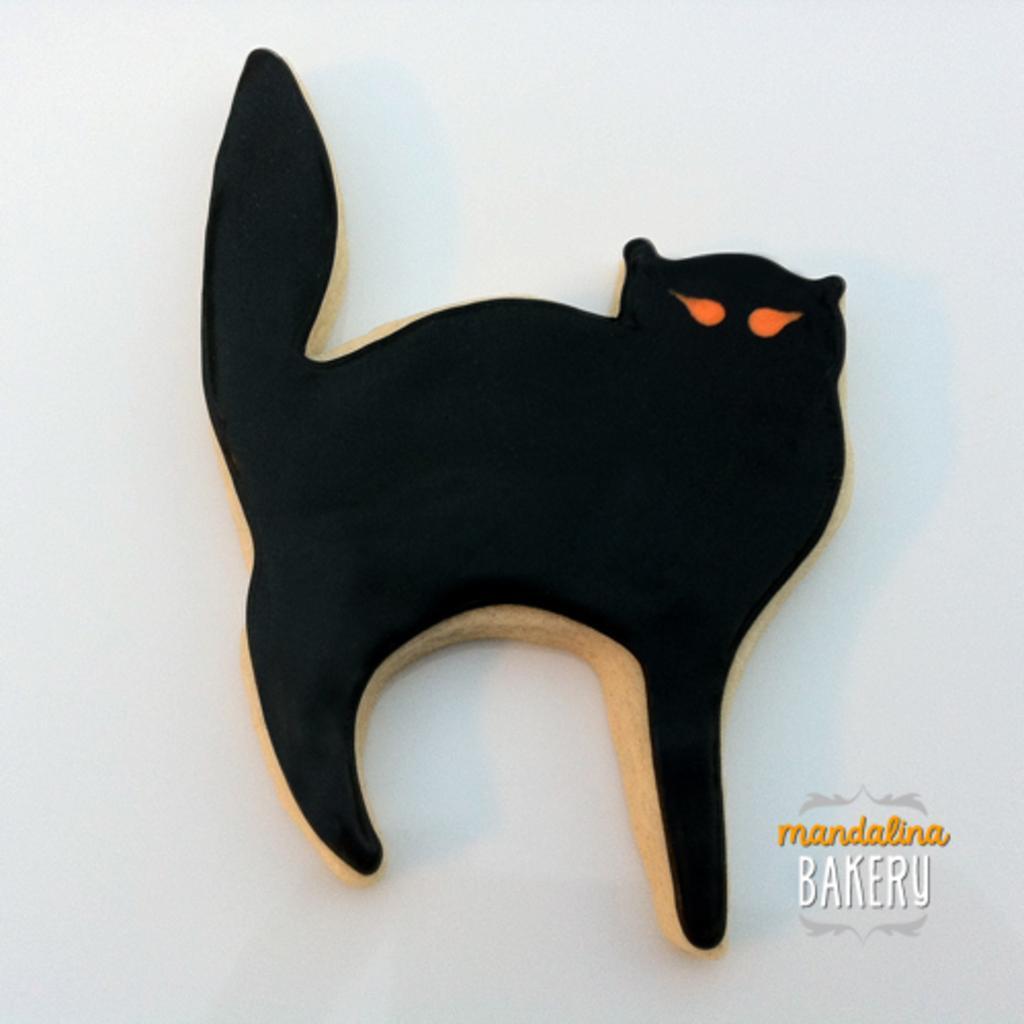In one or two sentences, can you explain what this image depicts? In the center of this picture we can see a black color object seems to be the sculpture of a cat. In the bottom right corner we can see the text on the image. The background of the image is white in color. 